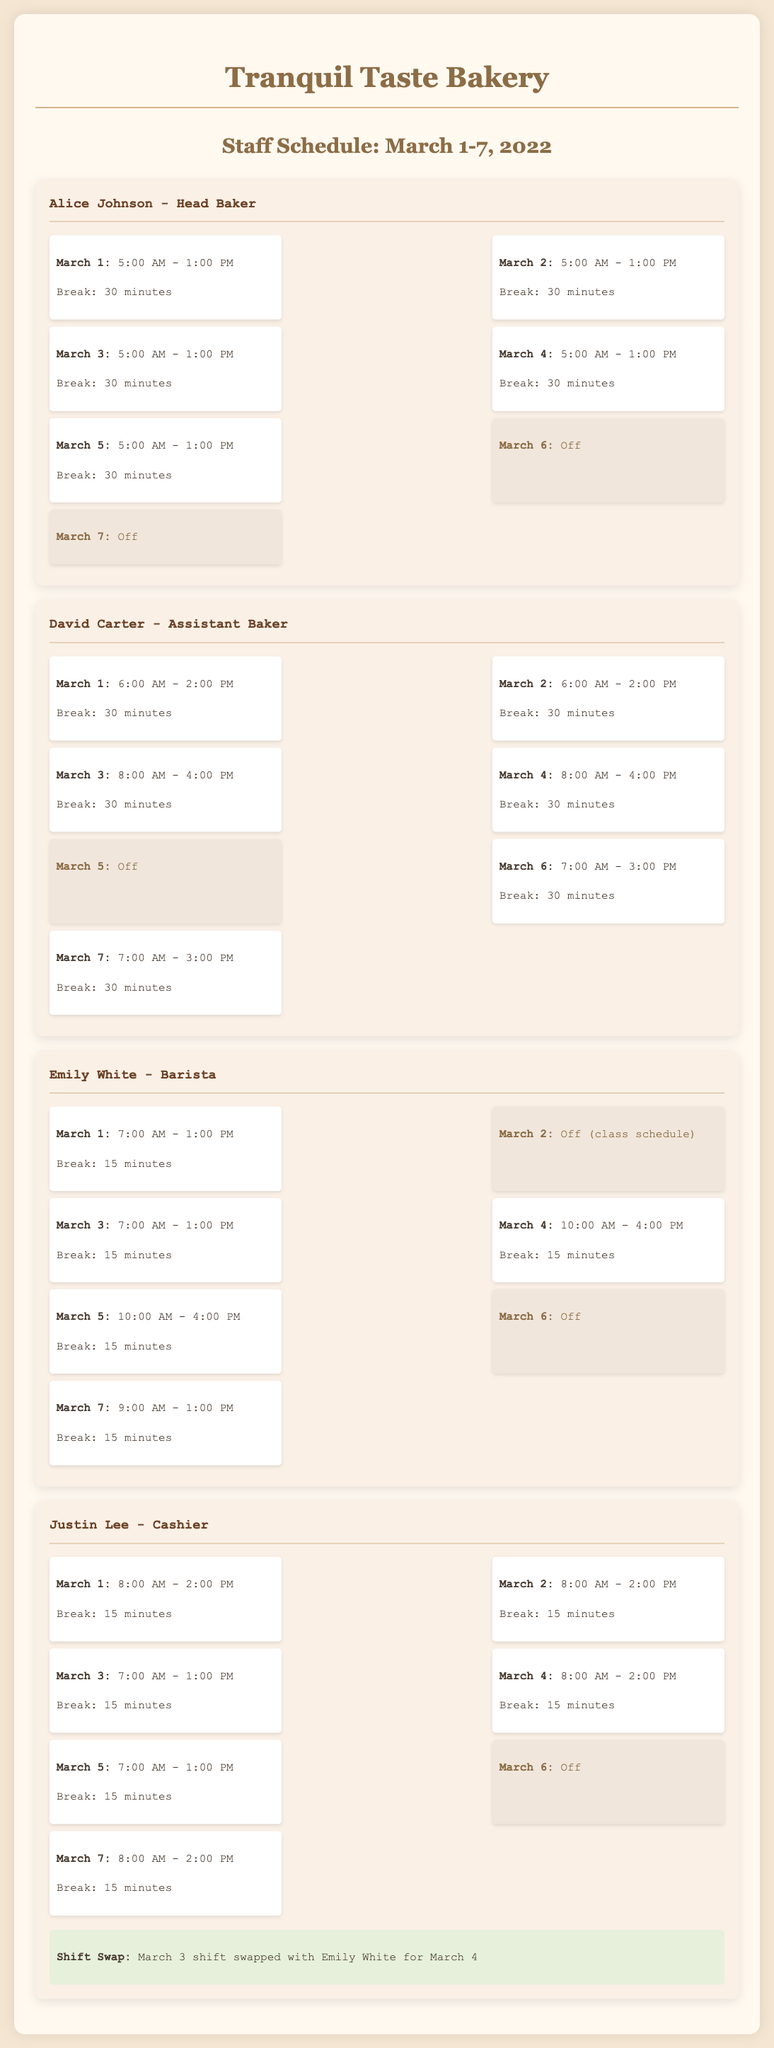what are the working hours for Alice Johnson on March 3? Alice Johnson's shift on March 3 is specified in the document as 5:00 AM - 1:00 PM.
Answer: 5:00 AM - 1:00 PM how many days is David Carter off during this week? David Carter has one day off, which is indicated as Off on March 5.
Answer: 1 what is Emily White's break duration on March 1? The document states that Emily White takes a 15-minute break on March 1.
Answer: 15 minutes who swapped shifts on March 3? The shift swap involved Justin Lee and Emily White, as indicated in the document.
Answer: Justin Lee and Emily White how many total shifts did Justin Lee work during the week? Justin Lee worked six shifts total during the week of March 1-7, 2022.
Answer: 6 what shift did David Carter work on March 4? David Carter's shift on March 4 is recorded as 8:00 AM - 4:00 PM.
Answer: 8:00 AM - 4:00 PM which employee has a class on March 2? The document notes that Emily White is off due to her class schedule on March 2.
Answer: Emily White what time does Emily White start her shift on March 7? The start time for Emily White on March 7 is indicated as 9:00 AM.
Answer: 9:00 AM 